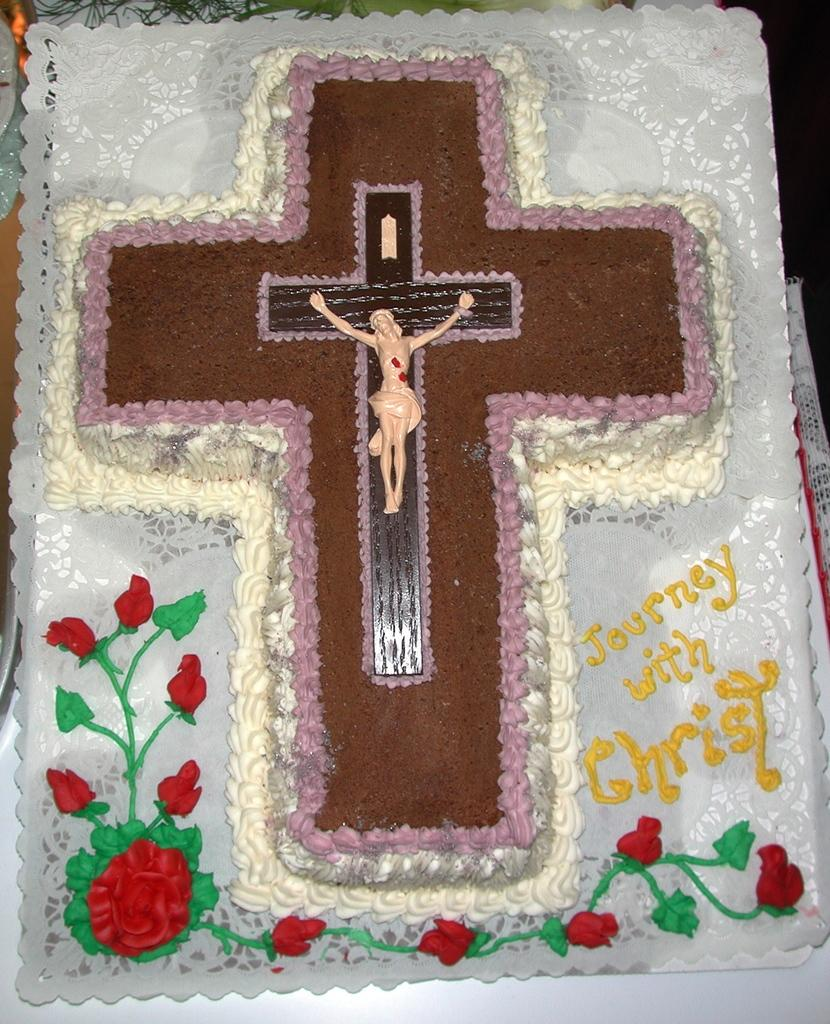What is the main object in the center of the image? There is a frame in the center of the image. What can be observed about the design of the frame? The frame has a design on it. What symbol is present on the frame? There is a cross on the frame. What message is conveyed by the frame? The frame has the words "Journey With Christ" written on it. How does the rat interact with the hook in the image? There is no rat or hook present in the image. Can you describe the kick performed by the person in the image? There are no people or kicks depicted in the image; it features a frame with a design, a cross, and the words "Journey With Christ." 